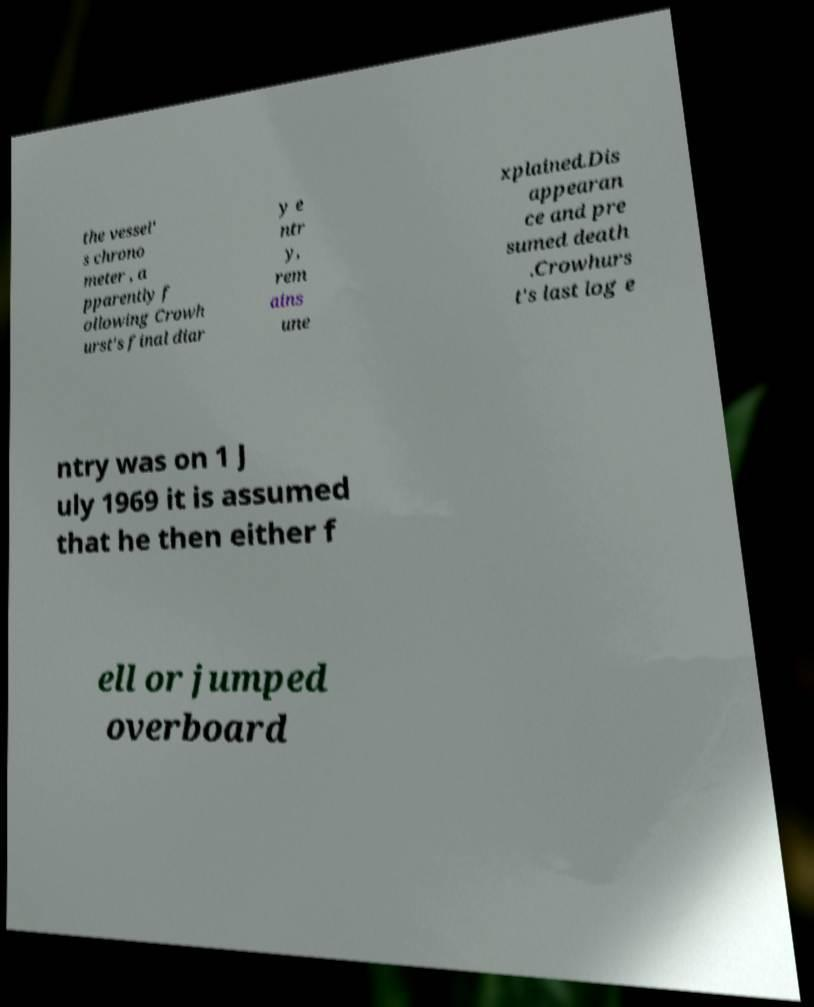For documentation purposes, I need the text within this image transcribed. Could you provide that? the vessel' s chrono meter , a pparently f ollowing Crowh urst's final diar y e ntr y, rem ains une xplained.Dis appearan ce and pre sumed death .Crowhurs t's last log e ntry was on 1 J uly 1969 it is assumed that he then either f ell or jumped overboard 